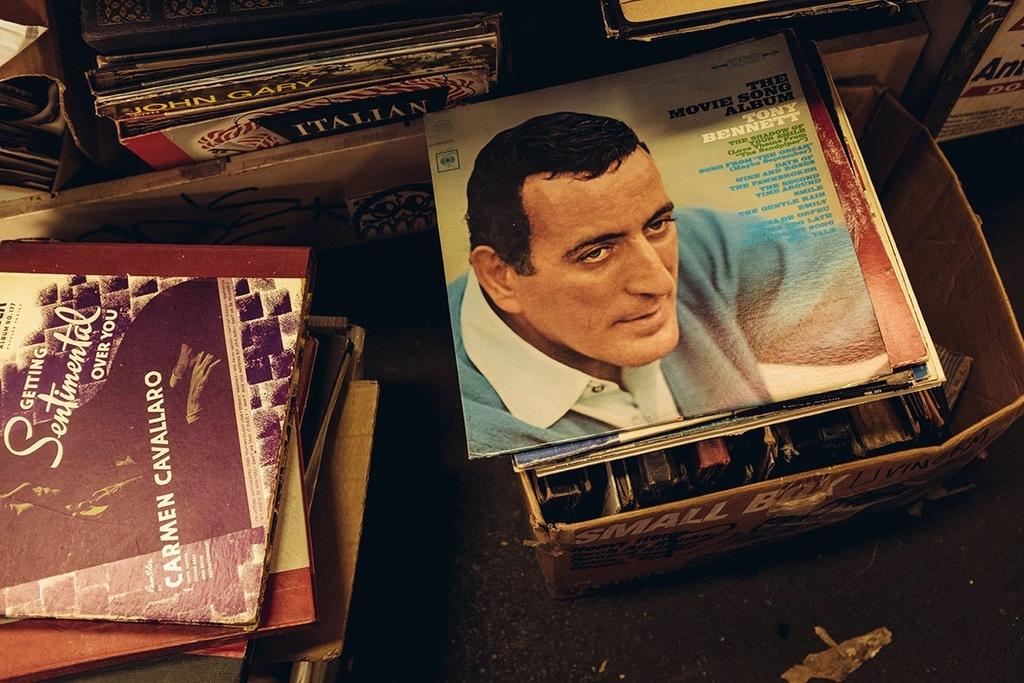Who is on the movie song albumn?
Offer a terse response. Tony bennett. What is the women's name on the left album?
Your answer should be very brief. Carmen cavallaro. 